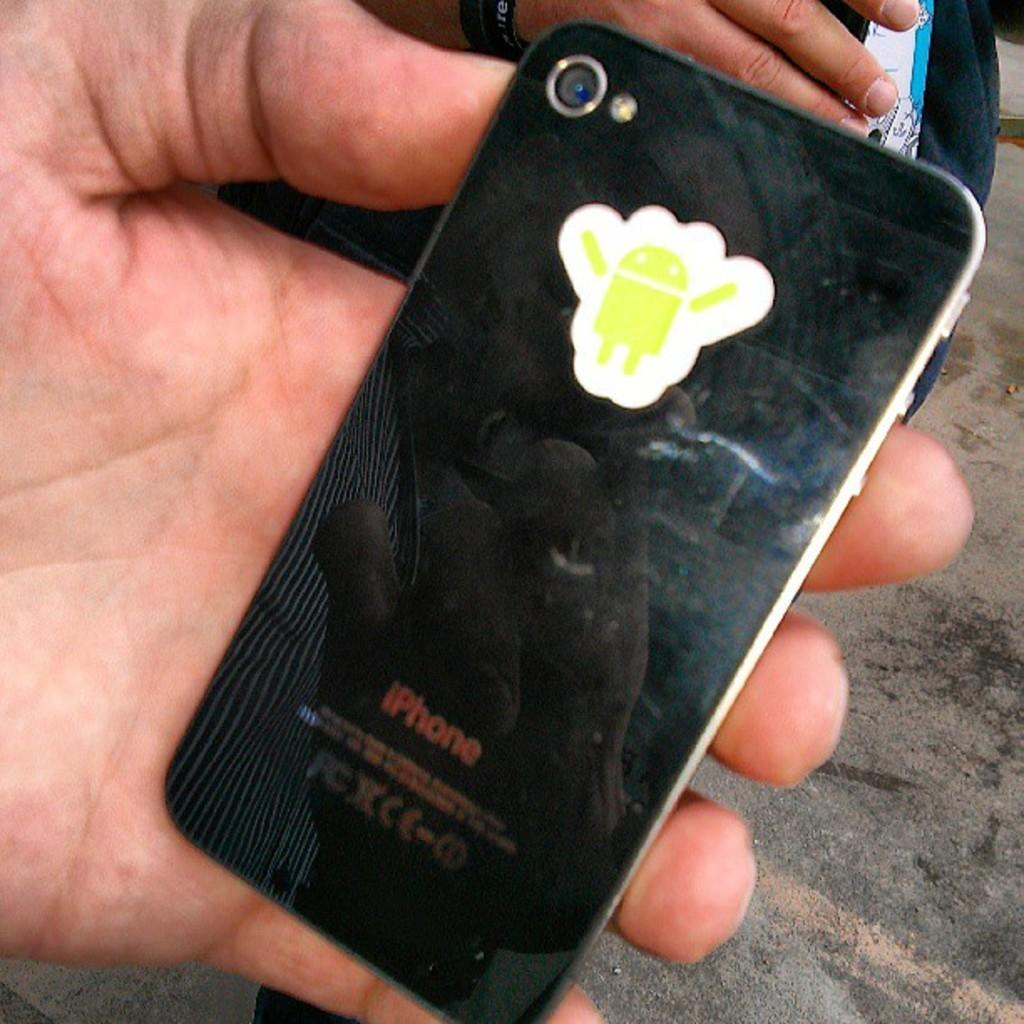What are the persons in the image doing? The persons in the image are sitting. Can you describe any objects that one of the persons is holding? One of the persons is holding a mobile phone in their hands. What type of gun can be seen in the image? There is no gun present in the image. What kind of rail is visible in the image? There is no rail visible in the image. 